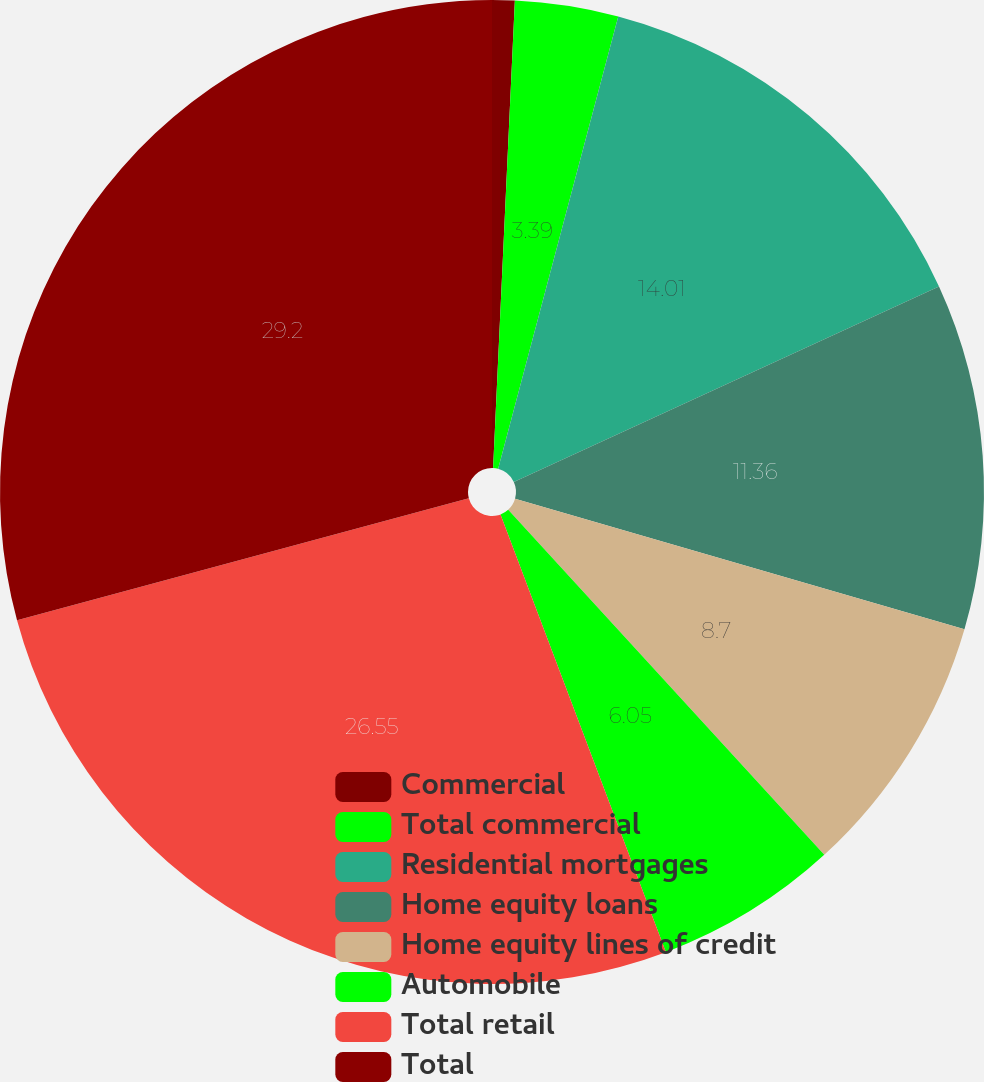Convert chart to OTSL. <chart><loc_0><loc_0><loc_500><loc_500><pie_chart><fcel>Commercial<fcel>Total commercial<fcel>Residential mortgages<fcel>Home equity loans<fcel>Home equity lines of credit<fcel>Automobile<fcel>Total retail<fcel>Total<nl><fcel>0.74%<fcel>3.39%<fcel>14.01%<fcel>11.36%<fcel>8.7%<fcel>6.05%<fcel>26.55%<fcel>29.2%<nl></chart> 